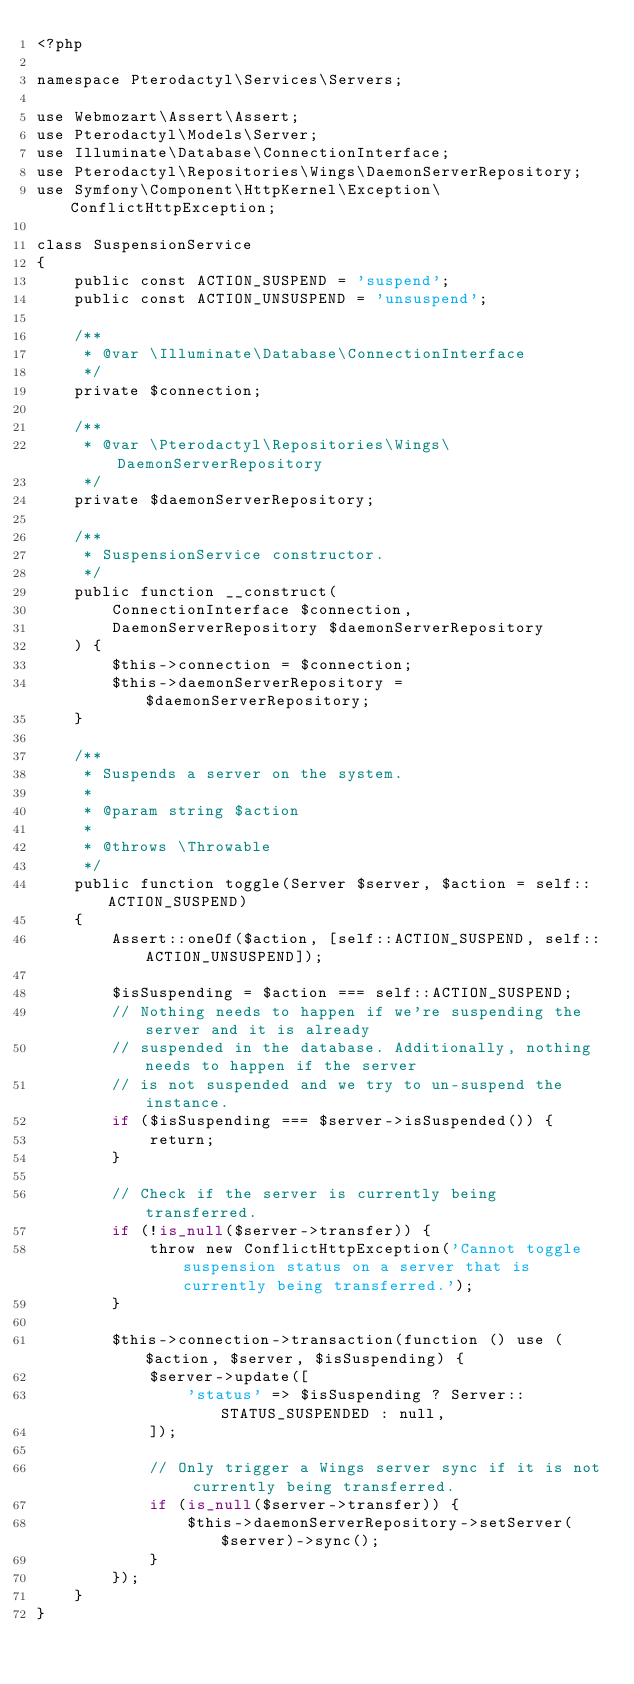<code> <loc_0><loc_0><loc_500><loc_500><_PHP_><?php

namespace Pterodactyl\Services\Servers;

use Webmozart\Assert\Assert;
use Pterodactyl\Models\Server;
use Illuminate\Database\ConnectionInterface;
use Pterodactyl\Repositories\Wings\DaemonServerRepository;
use Symfony\Component\HttpKernel\Exception\ConflictHttpException;

class SuspensionService
{
    public const ACTION_SUSPEND = 'suspend';
    public const ACTION_UNSUSPEND = 'unsuspend';

    /**
     * @var \Illuminate\Database\ConnectionInterface
     */
    private $connection;

    /**
     * @var \Pterodactyl\Repositories\Wings\DaemonServerRepository
     */
    private $daemonServerRepository;

    /**
     * SuspensionService constructor.
     */
    public function __construct(
        ConnectionInterface $connection,
        DaemonServerRepository $daemonServerRepository
    ) {
        $this->connection = $connection;
        $this->daemonServerRepository = $daemonServerRepository;
    }

    /**
     * Suspends a server on the system.
     *
     * @param string $action
     *
     * @throws \Throwable
     */
    public function toggle(Server $server, $action = self::ACTION_SUSPEND)
    {
        Assert::oneOf($action, [self::ACTION_SUSPEND, self::ACTION_UNSUSPEND]);

        $isSuspending = $action === self::ACTION_SUSPEND;
        // Nothing needs to happen if we're suspending the server and it is already
        // suspended in the database. Additionally, nothing needs to happen if the server
        // is not suspended and we try to un-suspend the instance.
        if ($isSuspending === $server->isSuspended()) {
            return;
        }

        // Check if the server is currently being transferred.
        if (!is_null($server->transfer)) {
            throw new ConflictHttpException('Cannot toggle suspension status on a server that is currently being transferred.');
        }

        $this->connection->transaction(function () use ($action, $server, $isSuspending) {
            $server->update([
                'status' => $isSuspending ? Server::STATUS_SUSPENDED : null,
            ]);

            // Only trigger a Wings server sync if it is not currently being transferred.
            if (is_null($server->transfer)) {
                $this->daemonServerRepository->setServer($server)->sync();
            }
        });
    }
}
</code> 